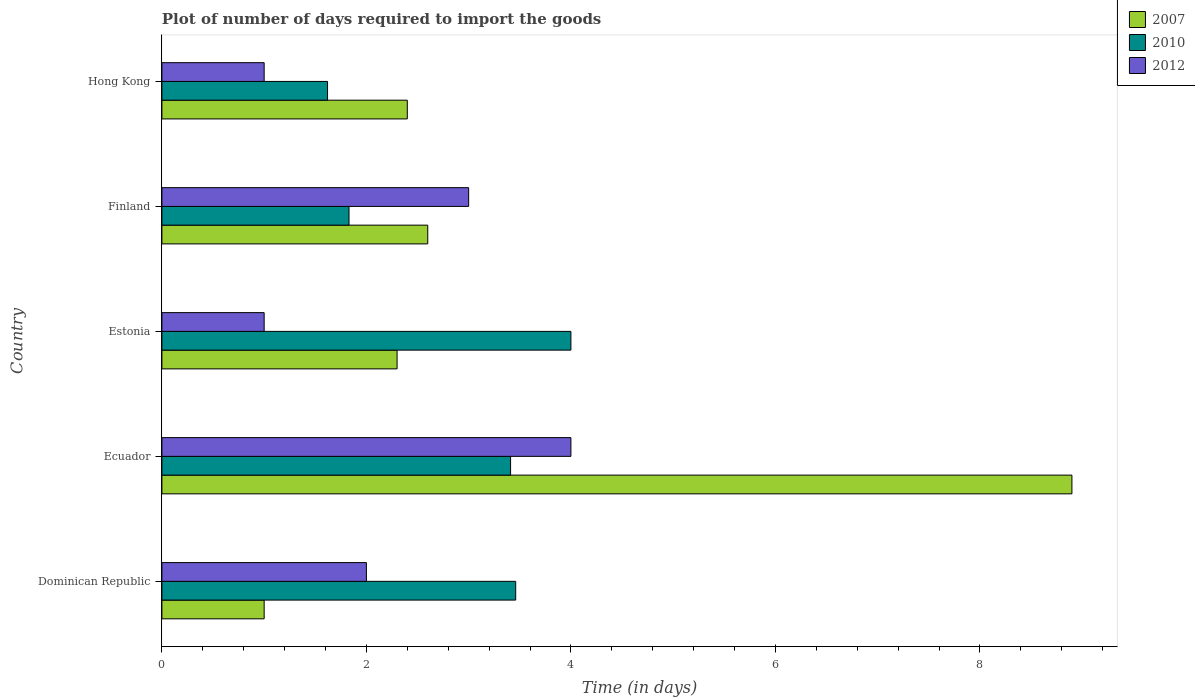Are the number of bars per tick equal to the number of legend labels?
Ensure brevity in your answer.  Yes. Are the number of bars on each tick of the Y-axis equal?
Your answer should be very brief. Yes. How many bars are there on the 4th tick from the bottom?
Make the answer very short. 3. What is the time required to import goods in 2010 in Ecuador?
Offer a very short reply. 3.41. Across all countries, what is the minimum time required to import goods in 2010?
Offer a terse response. 1.62. In which country was the time required to import goods in 2012 maximum?
Provide a succinct answer. Ecuador. In which country was the time required to import goods in 2012 minimum?
Provide a short and direct response. Estonia. What is the difference between the time required to import goods in 2010 in Ecuador and that in Hong Kong?
Offer a terse response. 1.79. What is the difference between the time required to import goods in 2007 in Estonia and the time required to import goods in 2010 in Hong Kong?
Keep it short and to the point. 0.68. What is the average time required to import goods in 2010 per country?
Your answer should be very brief. 2.86. What is the difference between the time required to import goods in 2010 and time required to import goods in 2007 in Ecuador?
Offer a very short reply. -5.49. What is the ratio of the time required to import goods in 2012 in Estonia to that in Hong Kong?
Make the answer very short. 1. What is the difference between the highest and the second highest time required to import goods in 2010?
Your answer should be compact. 0.54. What is the difference between the highest and the lowest time required to import goods in 2007?
Ensure brevity in your answer.  7.9. Is the sum of the time required to import goods in 2007 in Ecuador and Hong Kong greater than the maximum time required to import goods in 2010 across all countries?
Make the answer very short. Yes. What does the 1st bar from the bottom in Ecuador represents?
Make the answer very short. 2007. Is it the case that in every country, the sum of the time required to import goods in 2007 and time required to import goods in 2012 is greater than the time required to import goods in 2010?
Offer a terse response. No. Are all the bars in the graph horizontal?
Your answer should be very brief. Yes. Does the graph contain grids?
Provide a succinct answer. No. What is the title of the graph?
Offer a very short reply. Plot of number of days required to import the goods. Does "2010" appear as one of the legend labels in the graph?
Provide a short and direct response. Yes. What is the label or title of the X-axis?
Provide a succinct answer. Time (in days). What is the label or title of the Y-axis?
Your answer should be compact. Country. What is the Time (in days) in 2007 in Dominican Republic?
Provide a succinct answer. 1. What is the Time (in days) in 2010 in Dominican Republic?
Your response must be concise. 3.46. What is the Time (in days) in 2007 in Ecuador?
Give a very brief answer. 8.9. What is the Time (in days) of 2010 in Ecuador?
Offer a very short reply. 3.41. What is the Time (in days) of 2012 in Ecuador?
Your answer should be compact. 4. What is the Time (in days) of 2010 in Estonia?
Give a very brief answer. 4. What is the Time (in days) in 2007 in Finland?
Offer a very short reply. 2.6. What is the Time (in days) in 2010 in Finland?
Your answer should be compact. 1.83. What is the Time (in days) of 2010 in Hong Kong?
Your answer should be very brief. 1.62. Across all countries, what is the maximum Time (in days) of 2007?
Keep it short and to the point. 8.9. Across all countries, what is the maximum Time (in days) of 2012?
Provide a succinct answer. 4. Across all countries, what is the minimum Time (in days) in 2010?
Your answer should be compact. 1.62. Across all countries, what is the minimum Time (in days) of 2012?
Provide a succinct answer. 1. What is the total Time (in days) in 2007 in the graph?
Provide a succinct answer. 17.2. What is the total Time (in days) of 2010 in the graph?
Make the answer very short. 14.32. What is the difference between the Time (in days) of 2007 in Dominican Republic and that in Ecuador?
Ensure brevity in your answer.  -7.9. What is the difference between the Time (in days) in 2010 in Dominican Republic and that in Ecuador?
Offer a terse response. 0.05. What is the difference between the Time (in days) of 2007 in Dominican Republic and that in Estonia?
Your response must be concise. -1.3. What is the difference between the Time (in days) in 2010 in Dominican Republic and that in Estonia?
Give a very brief answer. -0.54. What is the difference between the Time (in days) in 2010 in Dominican Republic and that in Finland?
Provide a short and direct response. 1.63. What is the difference between the Time (in days) of 2012 in Dominican Republic and that in Finland?
Offer a terse response. -1. What is the difference between the Time (in days) of 2007 in Dominican Republic and that in Hong Kong?
Give a very brief answer. -1.4. What is the difference between the Time (in days) in 2010 in Dominican Republic and that in Hong Kong?
Offer a very short reply. 1.84. What is the difference between the Time (in days) in 2012 in Dominican Republic and that in Hong Kong?
Offer a very short reply. 1. What is the difference between the Time (in days) of 2007 in Ecuador and that in Estonia?
Provide a succinct answer. 6.6. What is the difference between the Time (in days) of 2010 in Ecuador and that in Estonia?
Ensure brevity in your answer.  -0.59. What is the difference between the Time (in days) of 2012 in Ecuador and that in Estonia?
Your answer should be compact. 3. What is the difference between the Time (in days) of 2007 in Ecuador and that in Finland?
Offer a terse response. 6.3. What is the difference between the Time (in days) in 2010 in Ecuador and that in Finland?
Your answer should be compact. 1.58. What is the difference between the Time (in days) of 2007 in Ecuador and that in Hong Kong?
Keep it short and to the point. 6.5. What is the difference between the Time (in days) in 2010 in Ecuador and that in Hong Kong?
Your response must be concise. 1.79. What is the difference between the Time (in days) of 2012 in Ecuador and that in Hong Kong?
Keep it short and to the point. 3. What is the difference between the Time (in days) in 2007 in Estonia and that in Finland?
Your answer should be compact. -0.3. What is the difference between the Time (in days) in 2010 in Estonia and that in Finland?
Keep it short and to the point. 2.17. What is the difference between the Time (in days) of 2012 in Estonia and that in Finland?
Make the answer very short. -2. What is the difference between the Time (in days) of 2010 in Estonia and that in Hong Kong?
Keep it short and to the point. 2.38. What is the difference between the Time (in days) in 2012 in Estonia and that in Hong Kong?
Ensure brevity in your answer.  0. What is the difference between the Time (in days) in 2007 in Finland and that in Hong Kong?
Ensure brevity in your answer.  0.2. What is the difference between the Time (in days) in 2010 in Finland and that in Hong Kong?
Offer a very short reply. 0.21. What is the difference between the Time (in days) in 2007 in Dominican Republic and the Time (in days) in 2010 in Ecuador?
Keep it short and to the point. -2.41. What is the difference between the Time (in days) in 2010 in Dominican Republic and the Time (in days) in 2012 in Ecuador?
Keep it short and to the point. -0.54. What is the difference between the Time (in days) of 2007 in Dominican Republic and the Time (in days) of 2010 in Estonia?
Your answer should be very brief. -3. What is the difference between the Time (in days) of 2007 in Dominican Republic and the Time (in days) of 2012 in Estonia?
Your answer should be compact. 0. What is the difference between the Time (in days) of 2010 in Dominican Republic and the Time (in days) of 2012 in Estonia?
Your response must be concise. 2.46. What is the difference between the Time (in days) of 2007 in Dominican Republic and the Time (in days) of 2010 in Finland?
Give a very brief answer. -0.83. What is the difference between the Time (in days) in 2010 in Dominican Republic and the Time (in days) in 2012 in Finland?
Your answer should be very brief. 0.46. What is the difference between the Time (in days) in 2007 in Dominican Republic and the Time (in days) in 2010 in Hong Kong?
Make the answer very short. -0.62. What is the difference between the Time (in days) in 2010 in Dominican Republic and the Time (in days) in 2012 in Hong Kong?
Give a very brief answer. 2.46. What is the difference between the Time (in days) of 2007 in Ecuador and the Time (in days) of 2012 in Estonia?
Offer a terse response. 7.9. What is the difference between the Time (in days) of 2010 in Ecuador and the Time (in days) of 2012 in Estonia?
Your answer should be very brief. 2.41. What is the difference between the Time (in days) in 2007 in Ecuador and the Time (in days) in 2010 in Finland?
Keep it short and to the point. 7.07. What is the difference between the Time (in days) in 2010 in Ecuador and the Time (in days) in 2012 in Finland?
Ensure brevity in your answer.  0.41. What is the difference between the Time (in days) of 2007 in Ecuador and the Time (in days) of 2010 in Hong Kong?
Make the answer very short. 7.28. What is the difference between the Time (in days) in 2007 in Ecuador and the Time (in days) in 2012 in Hong Kong?
Provide a succinct answer. 7.9. What is the difference between the Time (in days) of 2010 in Ecuador and the Time (in days) of 2012 in Hong Kong?
Give a very brief answer. 2.41. What is the difference between the Time (in days) of 2007 in Estonia and the Time (in days) of 2010 in Finland?
Your answer should be very brief. 0.47. What is the difference between the Time (in days) of 2010 in Estonia and the Time (in days) of 2012 in Finland?
Offer a terse response. 1. What is the difference between the Time (in days) of 2007 in Estonia and the Time (in days) of 2010 in Hong Kong?
Provide a succinct answer. 0.68. What is the difference between the Time (in days) of 2007 in Estonia and the Time (in days) of 2012 in Hong Kong?
Ensure brevity in your answer.  1.3. What is the difference between the Time (in days) in 2007 in Finland and the Time (in days) in 2010 in Hong Kong?
Provide a short and direct response. 0.98. What is the difference between the Time (in days) in 2010 in Finland and the Time (in days) in 2012 in Hong Kong?
Provide a succinct answer. 0.83. What is the average Time (in days) in 2007 per country?
Provide a succinct answer. 3.44. What is the average Time (in days) of 2010 per country?
Keep it short and to the point. 2.86. What is the difference between the Time (in days) in 2007 and Time (in days) in 2010 in Dominican Republic?
Give a very brief answer. -2.46. What is the difference between the Time (in days) of 2010 and Time (in days) of 2012 in Dominican Republic?
Your answer should be very brief. 1.46. What is the difference between the Time (in days) of 2007 and Time (in days) of 2010 in Ecuador?
Your answer should be very brief. 5.49. What is the difference between the Time (in days) in 2007 and Time (in days) in 2012 in Ecuador?
Your answer should be compact. 4.9. What is the difference between the Time (in days) in 2010 and Time (in days) in 2012 in Ecuador?
Ensure brevity in your answer.  -0.59. What is the difference between the Time (in days) in 2007 and Time (in days) in 2012 in Estonia?
Give a very brief answer. 1.3. What is the difference between the Time (in days) in 2010 and Time (in days) in 2012 in Estonia?
Provide a short and direct response. 3. What is the difference between the Time (in days) in 2007 and Time (in days) in 2010 in Finland?
Your response must be concise. 0.77. What is the difference between the Time (in days) in 2010 and Time (in days) in 2012 in Finland?
Your answer should be very brief. -1.17. What is the difference between the Time (in days) in 2007 and Time (in days) in 2010 in Hong Kong?
Keep it short and to the point. 0.78. What is the difference between the Time (in days) of 2010 and Time (in days) of 2012 in Hong Kong?
Your answer should be very brief. 0.62. What is the ratio of the Time (in days) in 2007 in Dominican Republic to that in Ecuador?
Give a very brief answer. 0.11. What is the ratio of the Time (in days) in 2010 in Dominican Republic to that in Ecuador?
Give a very brief answer. 1.01. What is the ratio of the Time (in days) of 2012 in Dominican Republic to that in Ecuador?
Ensure brevity in your answer.  0.5. What is the ratio of the Time (in days) in 2007 in Dominican Republic to that in Estonia?
Ensure brevity in your answer.  0.43. What is the ratio of the Time (in days) of 2010 in Dominican Republic to that in Estonia?
Keep it short and to the point. 0.86. What is the ratio of the Time (in days) in 2012 in Dominican Republic to that in Estonia?
Provide a succinct answer. 2. What is the ratio of the Time (in days) in 2007 in Dominican Republic to that in Finland?
Your response must be concise. 0.38. What is the ratio of the Time (in days) of 2010 in Dominican Republic to that in Finland?
Offer a terse response. 1.89. What is the ratio of the Time (in days) in 2012 in Dominican Republic to that in Finland?
Provide a short and direct response. 0.67. What is the ratio of the Time (in days) of 2007 in Dominican Republic to that in Hong Kong?
Offer a very short reply. 0.42. What is the ratio of the Time (in days) in 2010 in Dominican Republic to that in Hong Kong?
Your answer should be compact. 2.14. What is the ratio of the Time (in days) in 2007 in Ecuador to that in Estonia?
Your answer should be compact. 3.87. What is the ratio of the Time (in days) of 2010 in Ecuador to that in Estonia?
Offer a very short reply. 0.85. What is the ratio of the Time (in days) of 2007 in Ecuador to that in Finland?
Provide a succinct answer. 3.42. What is the ratio of the Time (in days) in 2010 in Ecuador to that in Finland?
Ensure brevity in your answer.  1.86. What is the ratio of the Time (in days) in 2007 in Ecuador to that in Hong Kong?
Offer a terse response. 3.71. What is the ratio of the Time (in days) of 2010 in Ecuador to that in Hong Kong?
Your answer should be compact. 2.1. What is the ratio of the Time (in days) of 2012 in Ecuador to that in Hong Kong?
Your answer should be compact. 4. What is the ratio of the Time (in days) in 2007 in Estonia to that in Finland?
Offer a very short reply. 0.88. What is the ratio of the Time (in days) of 2010 in Estonia to that in Finland?
Keep it short and to the point. 2.19. What is the ratio of the Time (in days) of 2010 in Estonia to that in Hong Kong?
Make the answer very short. 2.47. What is the ratio of the Time (in days) in 2010 in Finland to that in Hong Kong?
Give a very brief answer. 1.13. What is the ratio of the Time (in days) in 2012 in Finland to that in Hong Kong?
Your response must be concise. 3. What is the difference between the highest and the second highest Time (in days) in 2010?
Give a very brief answer. 0.54. What is the difference between the highest and the second highest Time (in days) in 2012?
Offer a very short reply. 1. What is the difference between the highest and the lowest Time (in days) in 2007?
Offer a very short reply. 7.9. What is the difference between the highest and the lowest Time (in days) in 2010?
Offer a terse response. 2.38. 